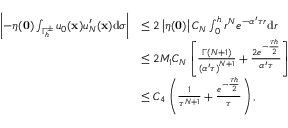Convert formula to latex. <formula><loc_0><loc_0><loc_500><loc_500>\begin{array} { r l } { \left | - \eta ( \mathbf 0 ) \int _ { { \Gamma _ { h } ^ { \pm } } } { { u _ { 0 } } ( \mathbf x ) } u _ { N } ^ { \prime } ( \mathbf x ) \mathrm d \sigma \right | } & { \leq 2 \left | \eta ( \mathbf 0 ) \right | C _ { N } \int _ { 0 } ^ { h } { { r ^ { N } } { e ^ { - \alpha ^ { \prime } \tau r } } \mathrm d r } } \\ & { \leq 2 M _ { 1 } C _ { N } \left [ { \frac { \Gamma ( N + 1 ) } { { { ( \alpha ^ { \prime } \tau ) } ^ { N + 1 } } } } + { \frac { 2 { e ^ { - { \frac { \tau h } { 2 } } } } } { \alpha ^ { \prime } \tau } } \right ] } \\ & { \leq { C _ { 4 } } \left ( { \frac { 1 } { { \tau ^ { N + 1 } } } } + { \frac { { e ^ { - { \frac { \tau h } { 2 } } } } } { \tau } } \right ) , } \end{array}</formula> 